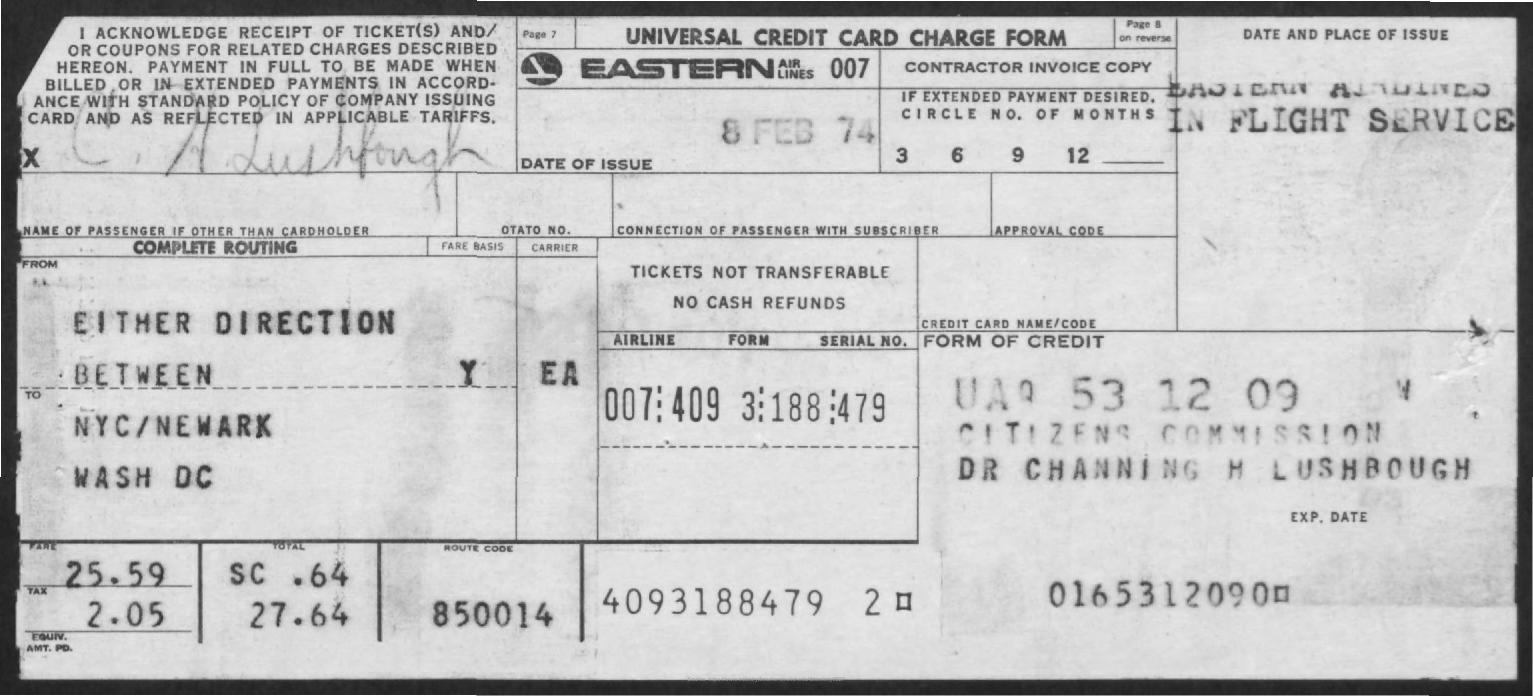Highlight a few significant elements in this photo. The amount of fine mentioned in the given form is 25.59... The date of issue mentioned in the given form is February 8, 1974. The amount of tax mentioned in the given form is 2.05%. The name of the form mentioned in the given page is the Universal Credit Card Charge Form. 